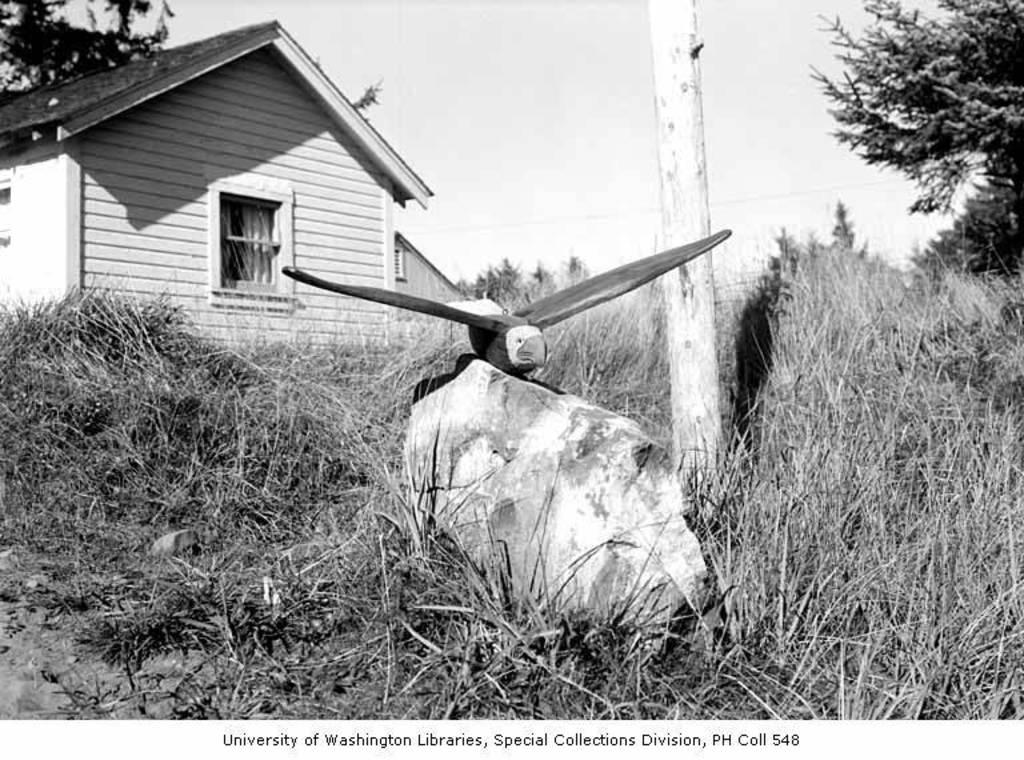<image>
Relay a brief, clear account of the picture shown. A black and white photograph that says, "University of Washington Libraries". 